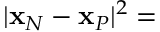<formula> <loc_0><loc_0><loc_500><loc_500>| { x } _ { N } - { x } _ { P } | ^ { 2 } =</formula> 